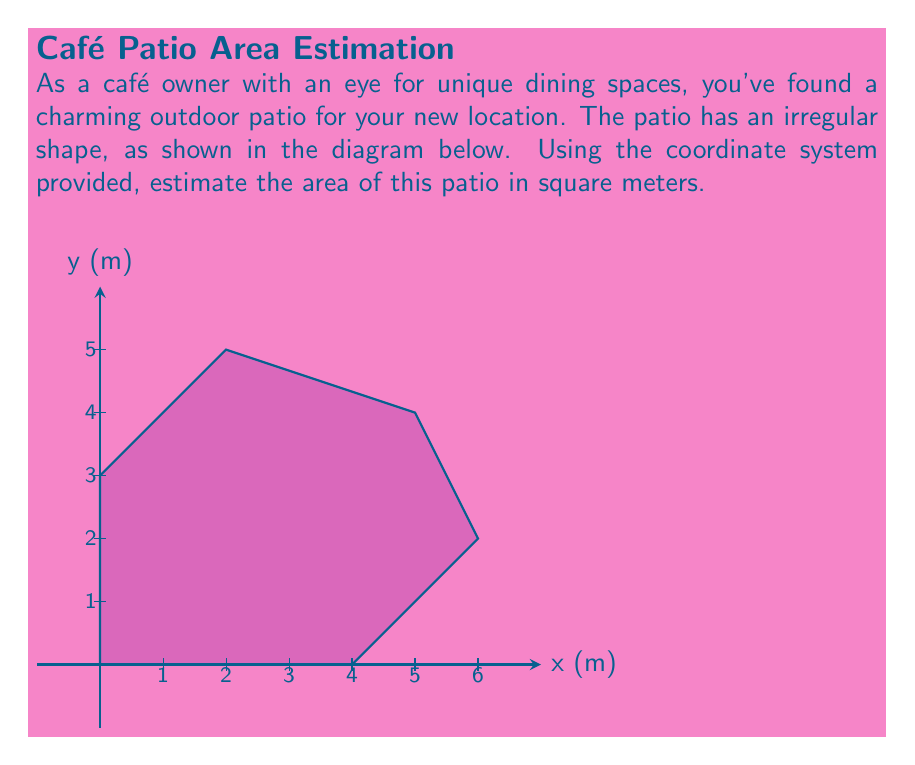Show me your answer to this math problem. To estimate the area of this irregular patio, we can use the method of dividing the shape into simpler geometric figures. In this case, we'll divide it into a rectangle and two triangles.

Step 1: Identify the shapes
- Rectangle: (0,0) to (4,3)
- Triangle 1: (4,0) to (6,2) to (4,3)
- Triangle 2: (0,3) to (2,5) to (5,4) to (4,3)

Step 2: Calculate the area of the rectangle
$A_{rectangle} = length \times width = 4 \times 3 = 12$ m²

Step 3: Calculate the area of Triangle 1
$A_{triangle1} = \frac{1}{2} \times base \times height = \frac{1}{2} \times 2 \times 2 = 2$ m²

Step 4: Calculate the area of Triangle 2
We can approximate this as a right triangle with base 5 and height 2:
$A_{triangle2} \approx \frac{1}{2} \times base \times height = \frac{1}{2} \times 5 \times 2 = 5$ m²

Step 5: Sum up all areas
$A_{total} = A_{rectangle} + A_{triangle1} + A_{triangle2}$
$A_{total} = 12 + 2 + 5 = 19$ m²

Therefore, the estimated area of the patio is approximately 19 square meters.
Answer: 19 m² 